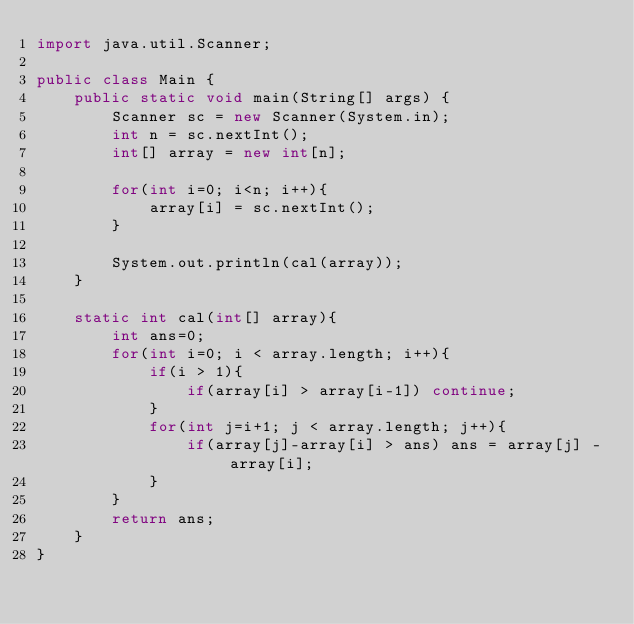<code> <loc_0><loc_0><loc_500><loc_500><_Java_>import java.util.Scanner;

public class Main {
    public static void main(String[] args) {
        Scanner sc = new Scanner(System.in);
        int n = sc.nextInt();
        int[] array = new int[n];

        for(int i=0; i<n; i++){
            array[i] = sc.nextInt();
        }

        System.out.println(cal(array));
    }

    static int cal(int[] array){
        int ans=0;
        for(int i=0; i < array.length; i++){
            if(i > 1){
                if(array[i] > array[i-1]) continue;
            }
            for(int j=i+1; j < array.length; j++){
                if(array[j]-array[i] > ans) ans = array[j] - array[i];
            }
        }
        return ans;
    }
}</code> 